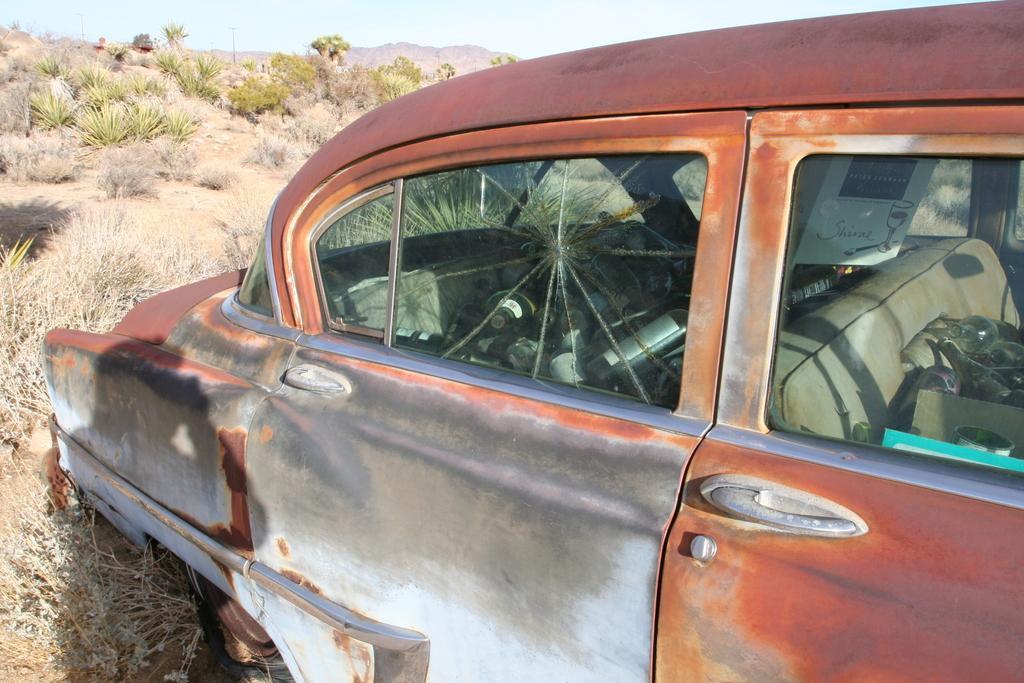Can you describe this image briefly? In this picture we can see car, grass, plants and trees. In the background of the image we can see hill and sky. 